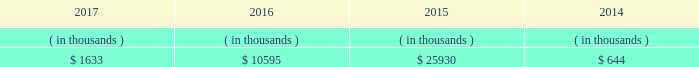Entergy mississippi may refinance , redeem , or otherwise retire debt and preferred stock prior to maturity , to the extent market conditions and interest and dividend rates are favorable .
All debt and common and preferred stock issuances by entergy mississippi require prior regulatory approval . a0 a0preferred stock and debt issuances are also subject to issuance tests set forth in its corporate charter , bond indenture , and other agreements . a0 a0entergy mississippi has sufficient capacity under these tests to meet its foreseeable capital needs .
Entergy mississippi 2019s receivables from the money pool were as follows as of december 31 for each of the following years. .
See note 4 to the financial statements for a description of the money pool .
Entergy mississippi has four separate credit facilities in the aggregate amount of $ 102.5 million scheduled to expire may 2018 .
No borrowings were outstanding under the credit facilities as of december a031 , 2017 . a0 a0in addition , entergy mississippi is a party to an uncommitted letter of credit facility as a means to post collateral to support its obligations to miso .
As of december a031 , 2017 , a $ 15.3 million letter of credit was outstanding under entergy mississippi 2019s uncommitted letter of credit facility .
See note 4 to the financial statements for additional discussion of the credit facilities .
Entergy mississippi obtained authorizations from the ferc through october 2019 for short-term borrowings not to exceed an aggregate amount of $ 175 million at any time outstanding and long-term borrowings and security issuances .
See note 4 to the financial statements for further discussion of entergy mississippi 2019s short-term borrowing limits .
Entergy mississippi , inc .
Management 2019s financial discussion and analysis state and local rate regulation and fuel-cost recovery the rates that entergy mississippi charges for electricity significantly influence its financial position , results of operations , and liquidity .
Entergy mississippi is regulated and the rates charged to its customers are determined in regulatory proceedings .
A governmental agency , the mpsc , is primarily responsible for approval of the rates charged to customers .
Formula rate plan in march 2016 , entergy mississippi submitted its formula rate plan 2016 test year filing showing entergy mississippi 2019s projected earned return for the 2016 calendar year to be below the formula rate plan bandwidth .
The filing showed a $ 32.6 million rate increase was necessary to reset entergy mississippi 2019s earned return on common equity to the specified point of adjustment of 9.96% ( 9.96 % ) , within the formula rate plan bandwidth .
In june 2016 the mpsc approved entergy mississippi 2019s joint stipulation with the mississippi public utilities staff .
The joint stipulation provided for a total revenue increase of $ 23.7 million .
The revenue increase includes a $ 19.4 million increase through the formula rate plan , resulting in a return on common equity point of adjustment of 10.07% ( 10.07 % ) .
The revenue increase also includes $ 4.3 million in incremental ad valorem tax expenses to be collected through an updated ad valorem tax adjustment rider .
The revenue increase and ad valorem tax adjustment rider were effective with the july 2016 bills .
In march 2017 , entergy mississippi submitted its formula rate plan 2017 test year filing and 2016 look-back filing showing entergy mississippi 2019s earned return for the historical 2016 calendar year and projected earned return for the 2017 calendar year to be within the formula rate plan bandwidth , resulting in no change in rates .
In june 2017 , entergy mississippi and the mississippi public utilities staff entered into a stipulation that confirmed that entergy .
What was the percent of the joint stipulation approve revenue increase based on formula rates? 
Computations: (19.4 / 23.7)
Answer: 0.81857. 